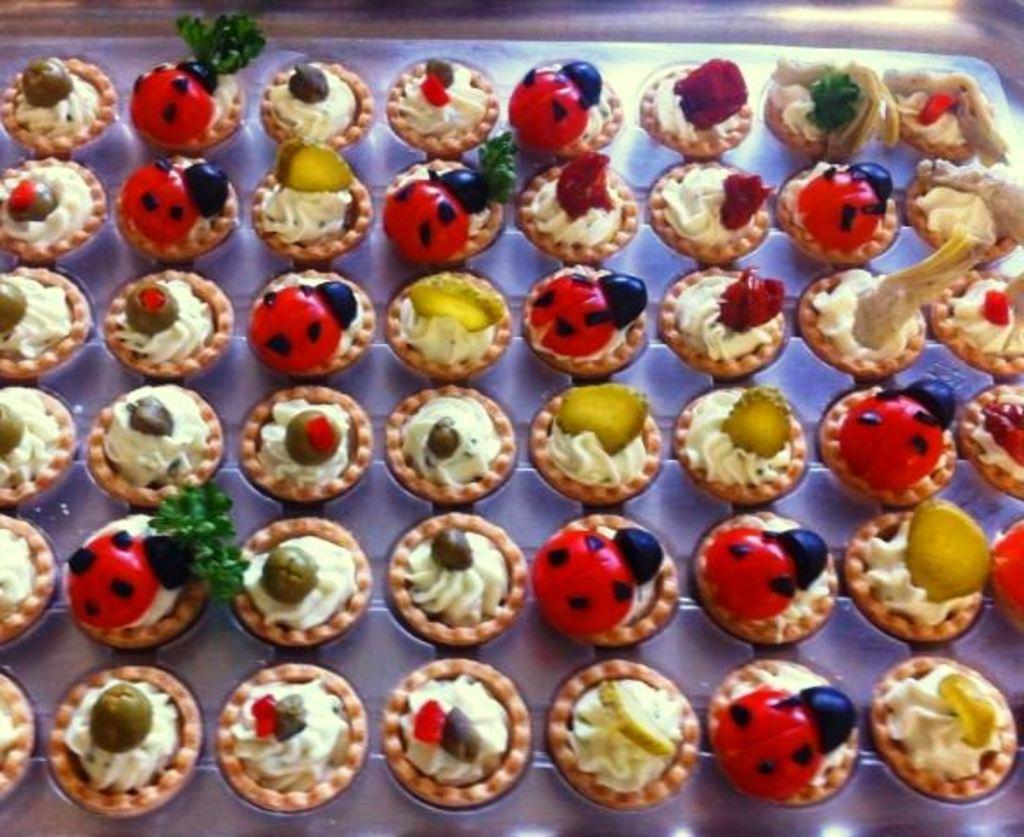Please provide a concise description of this image. In this image I can see some cupcakes on a table which is covered with a white color cloth. On the cupcakes I can see the cream in red and white colors and also I can see some fruit slices. 